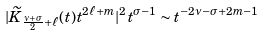Convert formula to latex. <formula><loc_0><loc_0><loc_500><loc_500>| \widetilde { K } _ { \frac { \nu + \sigma } { 2 } + \ell } ( t ) t ^ { 2 \ell + m } | ^ { 2 } t ^ { \sigma - 1 } \sim t ^ { - 2 \nu - \sigma + 2 m - 1 }</formula> 